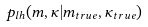<formula> <loc_0><loc_0><loc_500><loc_500>p _ { l h } ( m , \kappa | m _ { t r u e } , \kappa _ { t r u e } )</formula> 